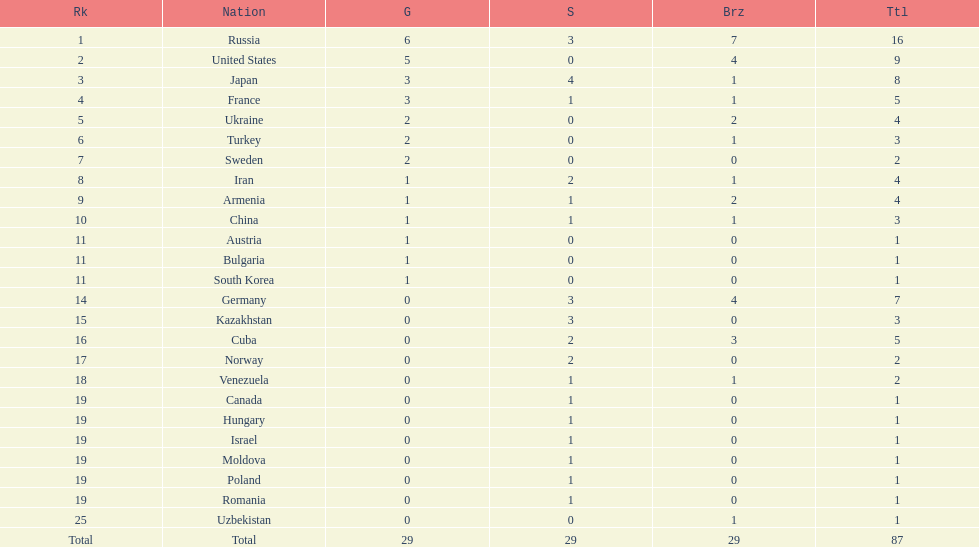What is the total amount of nations with more than 5 bronze medals? 1. Could you parse the entire table as a dict? {'header': ['Rk', 'Nation', 'G', 'S', 'Brz', 'Ttl'], 'rows': [['1', 'Russia', '6', '3', '7', '16'], ['2', 'United States', '5', '0', '4', '9'], ['3', 'Japan', '3', '4', '1', '8'], ['4', 'France', '3', '1', '1', '5'], ['5', 'Ukraine', '2', '0', '2', '4'], ['6', 'Turkey', '2', '0', '1', '3'], ['7', 'Sweden', '2', '0', '0', '2'], ['8', 'Iran', '1', '2', '1', '4'], ['9', 'Armenia', '1', '1', '2', '4'], ['10', 'China', '1', '1', '1', '3'], ['11', 'Austria', '1', '0', '0', '1'], ['11', 'Bulgaria', '1', '0', '0', '1'], ['11', 'South Korea', '1', '0', '0', '1'], ['14', 'Germany', '0', '3', '4', '7'], ['15', 'Kazakhstan', '0', '3', '0', '3'], ['16', 'Cuba', '0', '2', '3', '5'], ['17', 'Norway', '0', '2', '0', '2'], ['18', 'Venezuela', '0', '1', '1', '2'], ['19', 'Canada', '0', '1', '0', '1'], ['19', 'Hungary', '0', '1', '0', '1'], ['19', 'Israel', '0', '1', '0', '1'], ['19', 'Moldova', '0', '1', '0', '1'], ['19', 'Poland', '0', '1', '0', '1'], ['19', 'Romania', '0', '1', '0', '1'], ['25', 'Uzbekistan', '0', '0', '1', '1'], ['Total', 'Total', '29', '29', '29', '87']]} 